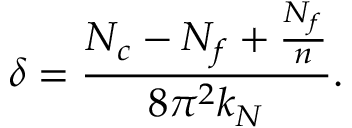<formula> <loc_0><loc_0><loc_500><loc_500>\delta = \frac { N _ { c } - N _ { f } + \frac { N _ { f } } { n } } { 8 \pi ^ { 2 } k _ { N } } .</formula> 